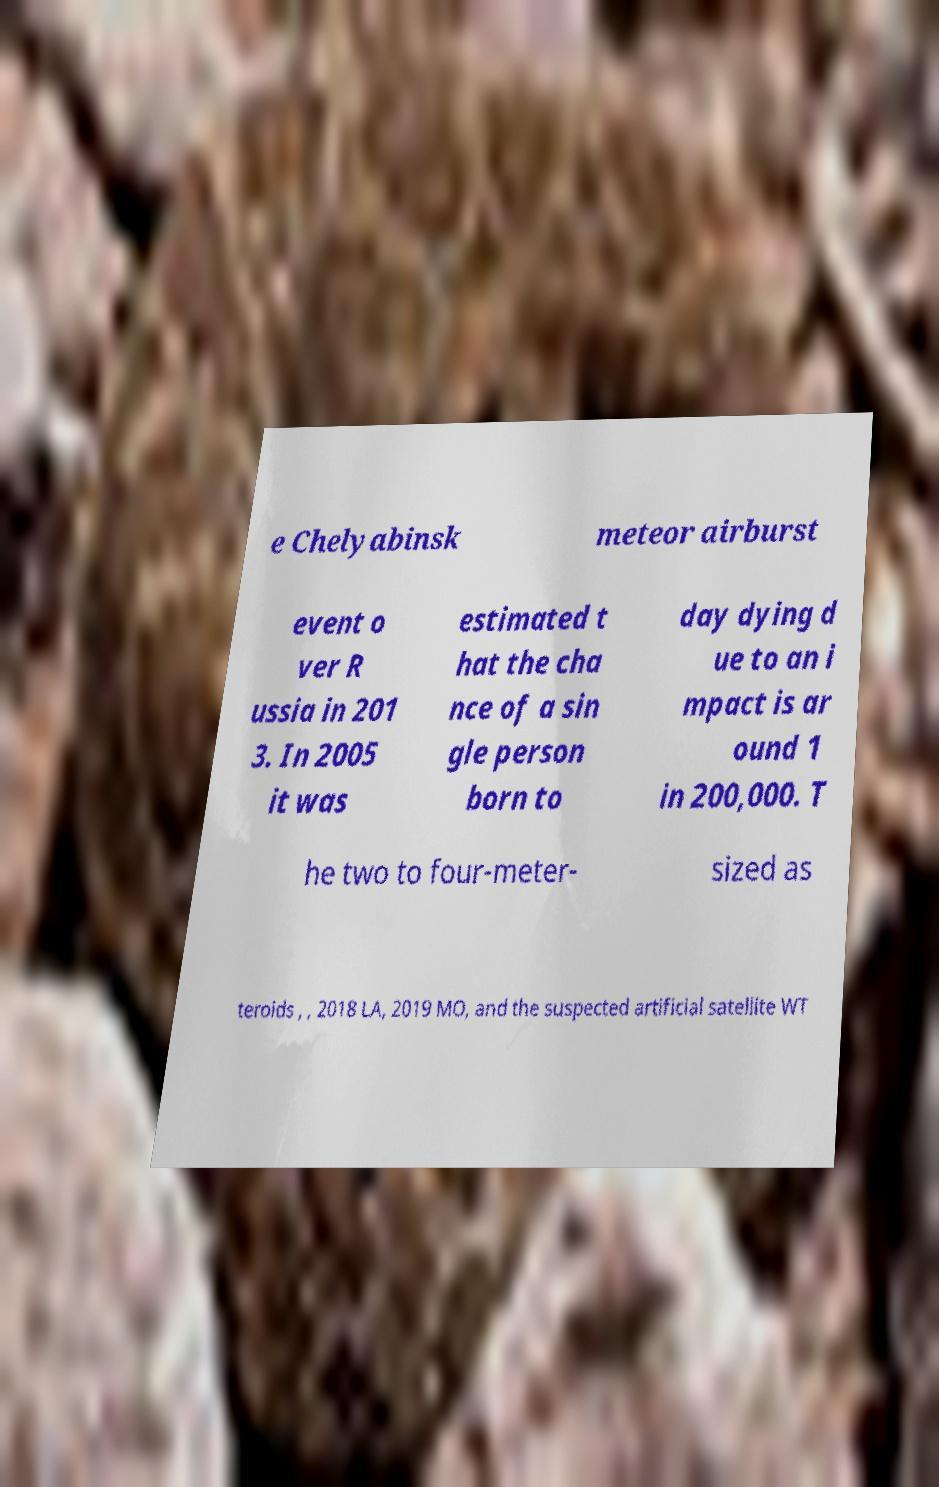Can you read and provide the text displayed in the image?This photo seems to have some interesting text. Can you extract and type it out for me? e Chelyabinsk meteor airburst event o ver R ussia in 201 3. In 2005 it was estimated t hat the cha nce of a sin gle person born to day dying d ue to an i mpact is ar ound 1 in 200,000. T he two to four-meter- sized as teroids , , 2018 LA, 2019 MO, and the suspected artificial satellite WT 